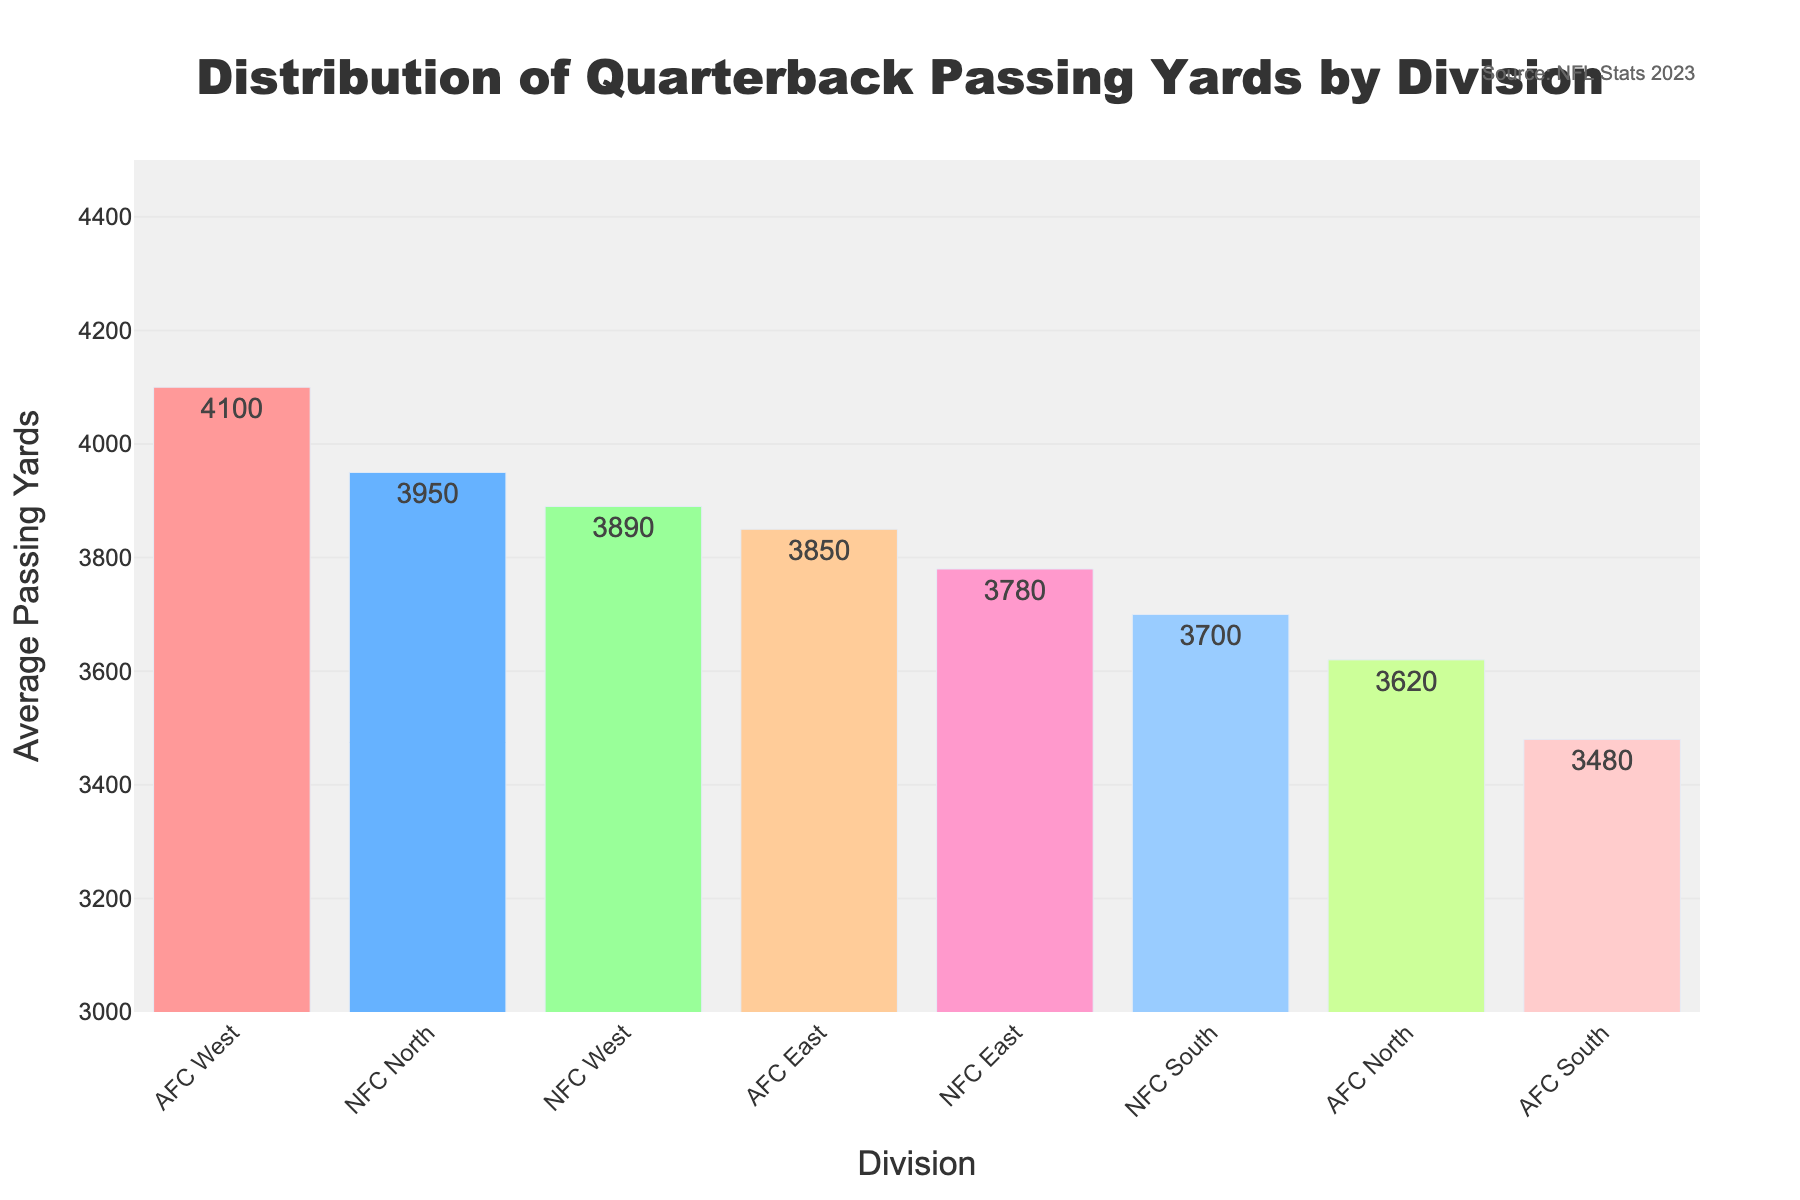Which division has the highest average passing yards? By referring to the heights of the bars, the AFC West has the tallest bar indicating it has the highest average passing yards.
Answer: AFC West Which division has the lowest average passing yards? By looking at the height of the bars, the AFC South has the shortest bar which means it has the lowest average passing yards.
Answer: AFC South How does the average passing yards of the NFC East compare to the NFC North? NFC North (3950) has a slightly higher average passing yards compared to NFC East (3780). This can be observed by comparing the height of the respective bars.
Answer: NFC North has higher average passing yards What is the sum of average passing yards for AFC East and AFC West? AFC East has 3850 and AFC West has 4100 average passing yards. Adding them together, 3850 + 4100 = 7950.
Answer: 7950 What is the difference between the average passing yards of the AFC East and NFC South? Subtracting the average passing yards of the NFC South (3700) from the AFC East (3850), the difference is 150.
Answer: 150 Which division in the NFC has the lowest average passing yards? The bar representing the NFC South division is the shortest among the NFC divisions, indicating the lowest average passing yards at 3700.
Answer: NFC South What is the average (mean) passing yards for the NFC divisions? Sum the average passing yards for NFC East (3780), NFC North (3950), NFC South (3700), and NFC West (3890), then divide by 4. (3780 + 3950 + 3700 + 3890) / 4 = 3830.
Answer: 3830 Compare the average passing yards of AFC North and NFC West. Which one is higher? The bar for NFC West (3890) is taller than for AFC North (3620), indicating NFC West has higher average passing yards.
Answer: NFC West What color is the bar representing the AFC West division? The AFC West bar is colored in one of the warm hues, which is an orange shade in the chart.
Answer: Orange 